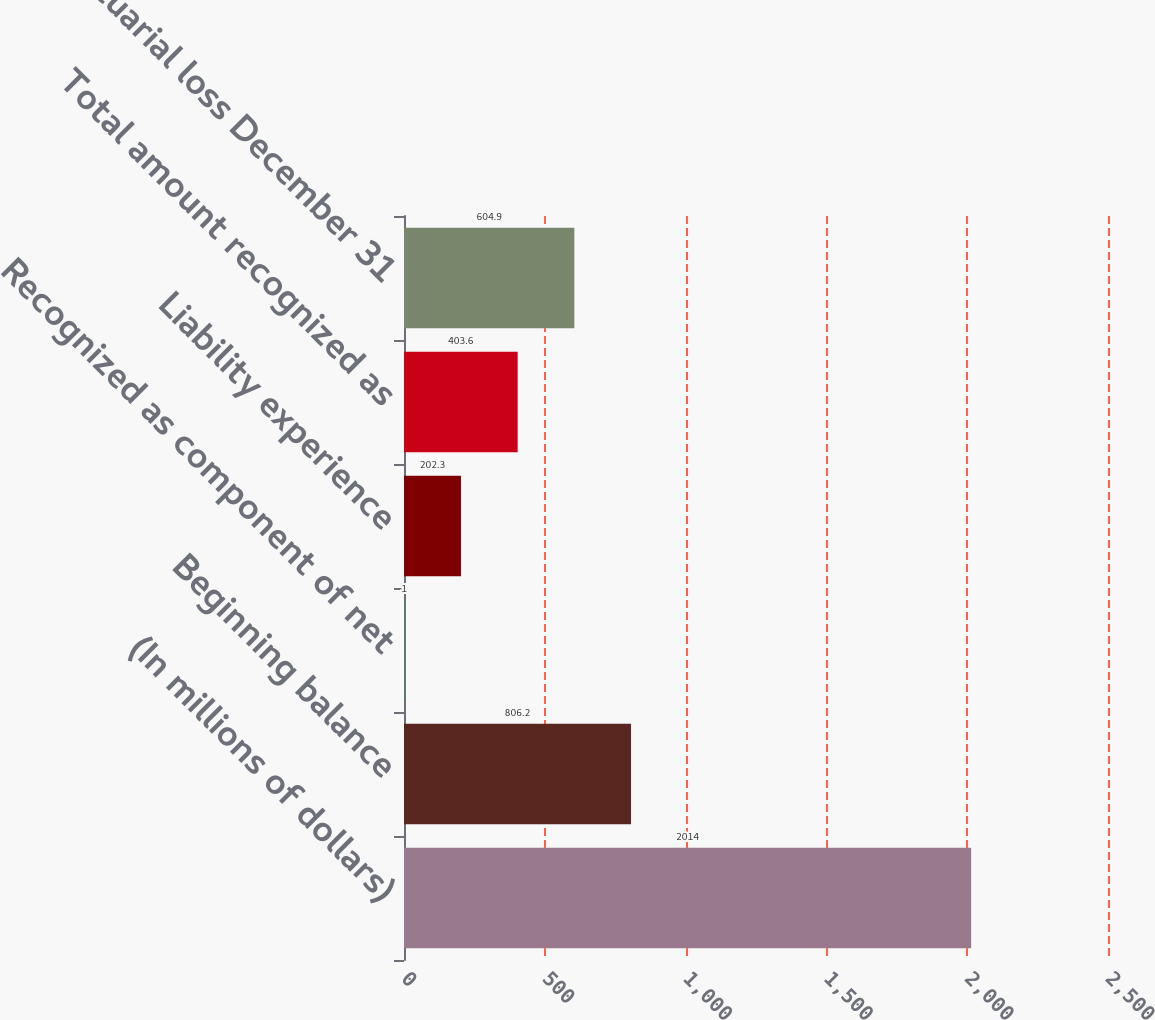Convert chart. <chart><loc_0><loc_0><loc_500><loc_500><bar_chart><fcel>(In millions of dollars)<fcel>Beginning balance<fcel>Recognized as component of net<fcel>Liability experience<fcel>Total amount recognized as<fcel>Net actuarial loss December 31<nl><fcel>2014<fcel>806.2<fcel>1<fcel>202.3<fcel>403.6<fcel>604.9<nl></chart> 